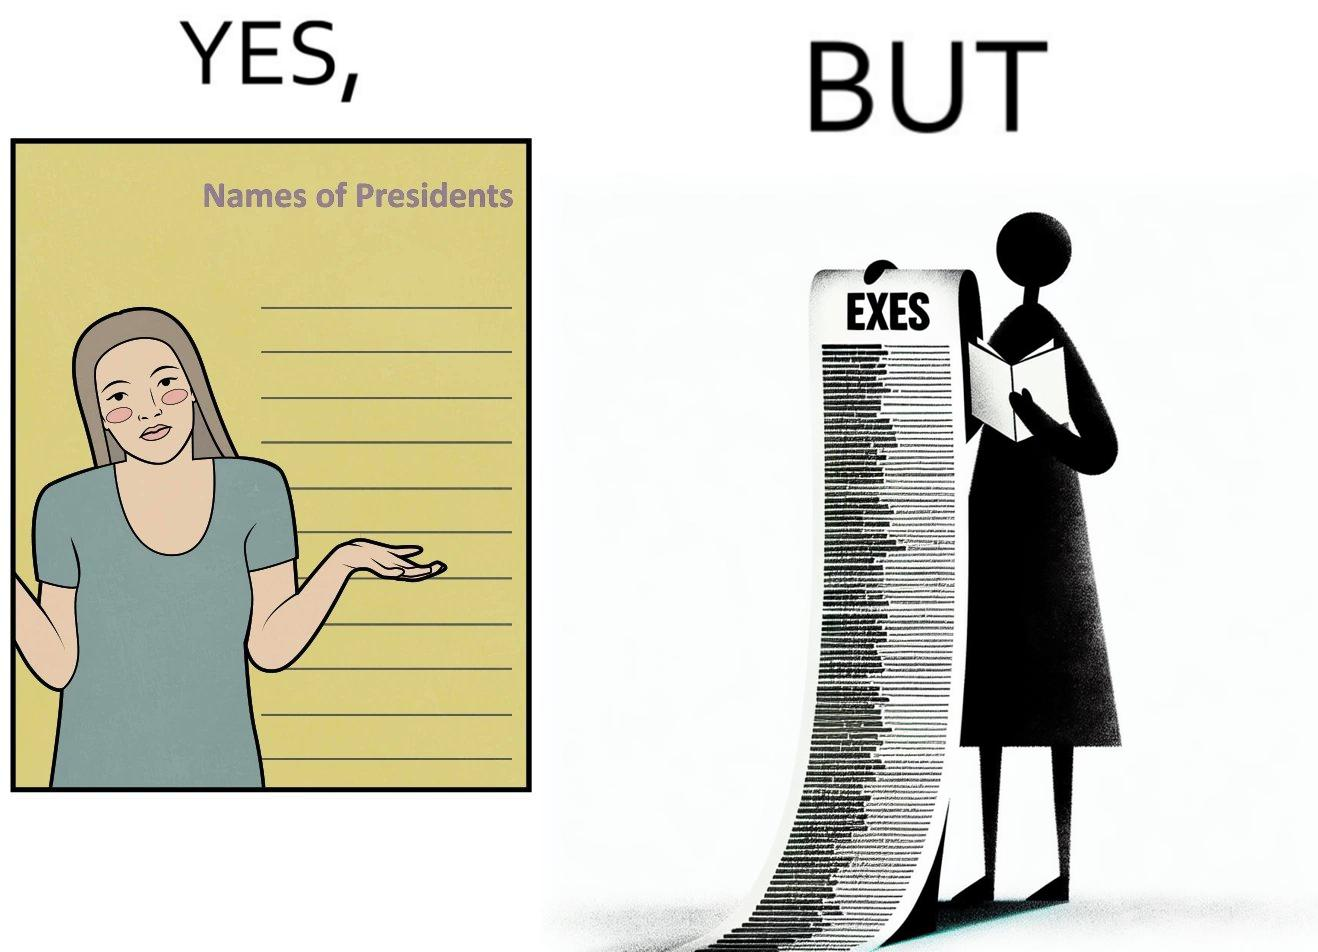What do you see in each half of this image? In the left part of the image: It is a woman who does not know the names of presidents In the right part of the image: It is a woman who has written down a list of "his"
Exes 